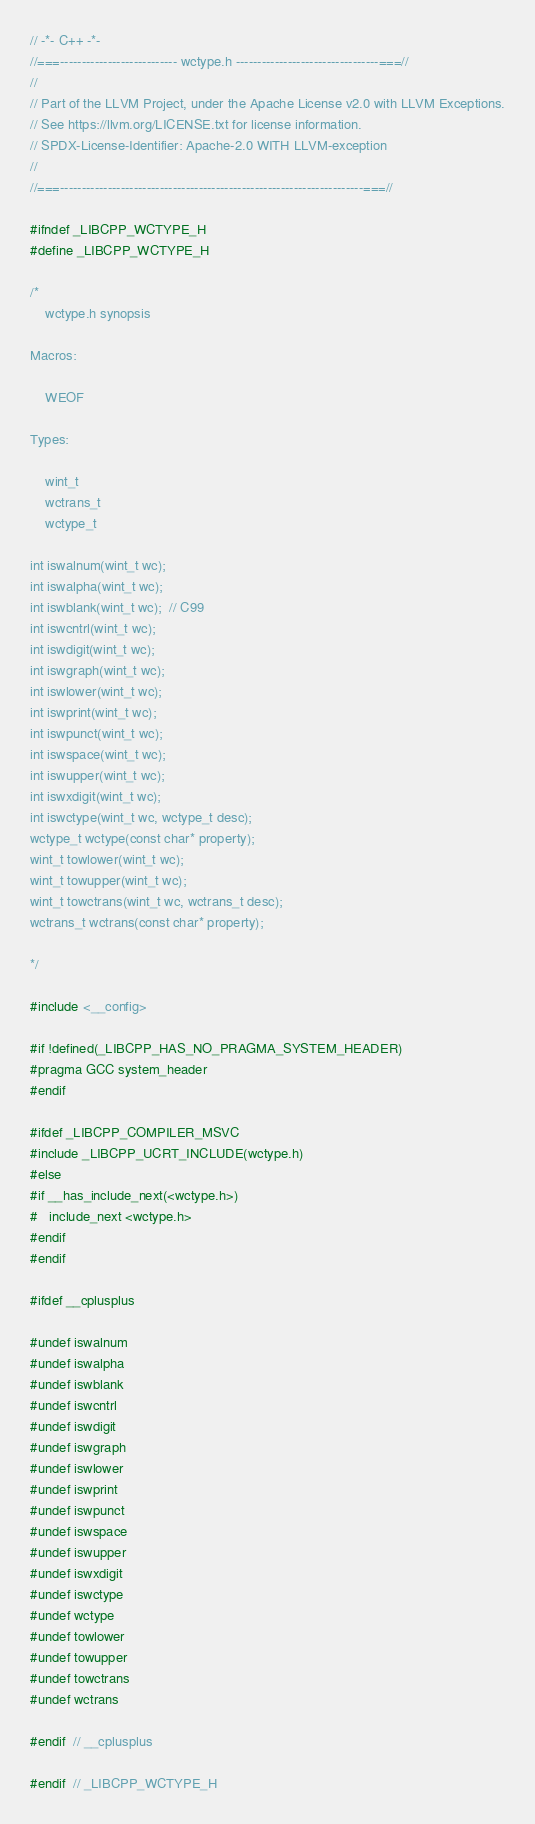<code> <loc_0><loc_0><loc_500><loc_500><_C_>// -*- C++ -*-
//===--------------------------- wctype.h ---------------------------------===//
//
// Part of the LLVM Project, under the Apache License v2.0 with LLVM Exceptions.
// See https://llvm.org/LICENSE.txt for license information.
// SPDX-License-Identifier: Apache-2.0 WITH LLVM-exception
//
//===----------------------------------------------------------------------===//

#ifndef _LIBCPP_WCTYPE_H
#define _LIBCPP_WCTYPE_H

/*
    wctype.h synopsis

Macros:

    WEOF

Types:

    wint_t
    wctrans_t
    wctype_t

int iswalnum(wint_t wc);
int iswalpha(wint_t wc);
int iswblank(wint_t wc);  // C99
int iswcntrl(wint_t wc);
int iswdigit(wint_t wc);
int iswgraph(wint_t wc);
int iswlower(wint_t wc);
int iswprint(wint_t wc);
int iswpunct(wint_t wc);
int iswspace(wint_t wc);
int iswupper(wint_t wc);
int iswxdigit(wint_t wc);
int iswctype(wint_t wc, wctype_t desc);
wctype_t wctype(const char* property);
wint_t towlower(wint_t wc);
wint_t towupper(wint_t wc);
wint_t towctrans(wint_t wc, wctrans_t desc);
wctrans_t wctrans(const char* property);

*/

#include <__config>

#if !defined(_LIBCPP_HAS_NO_PRAGMA_SYSTEM_HEADER)
#pragma GCC system_header
#endif

#ifdef _LIBCPP_COMPILER_MSVC
#include _LIBCPP_UCRT_INCLUDE(wctype.h)
#else
#if __has_include_next(<wctype.h>)
#   include_next <wctype.h>
#endif
#endif

#ifdef __cplusplus

#undef iswalnum
#undef iswalpha
#undef iswblank
#undef iswcntrl
#undef iswdigit
#undef iswgraph
#undef iswlower
#undef iswprint
#undef iswpunct
#undef iswspace
#undef iswupper
#undef iswxdigit
#undef iswctype
#undef wctype
#undef towlower
#undef towupper
#undef towctrans
#undef wctrans

#endif  // __cplusplus

#endif  // _LIBCPP_WCTYPE_H
</code> 